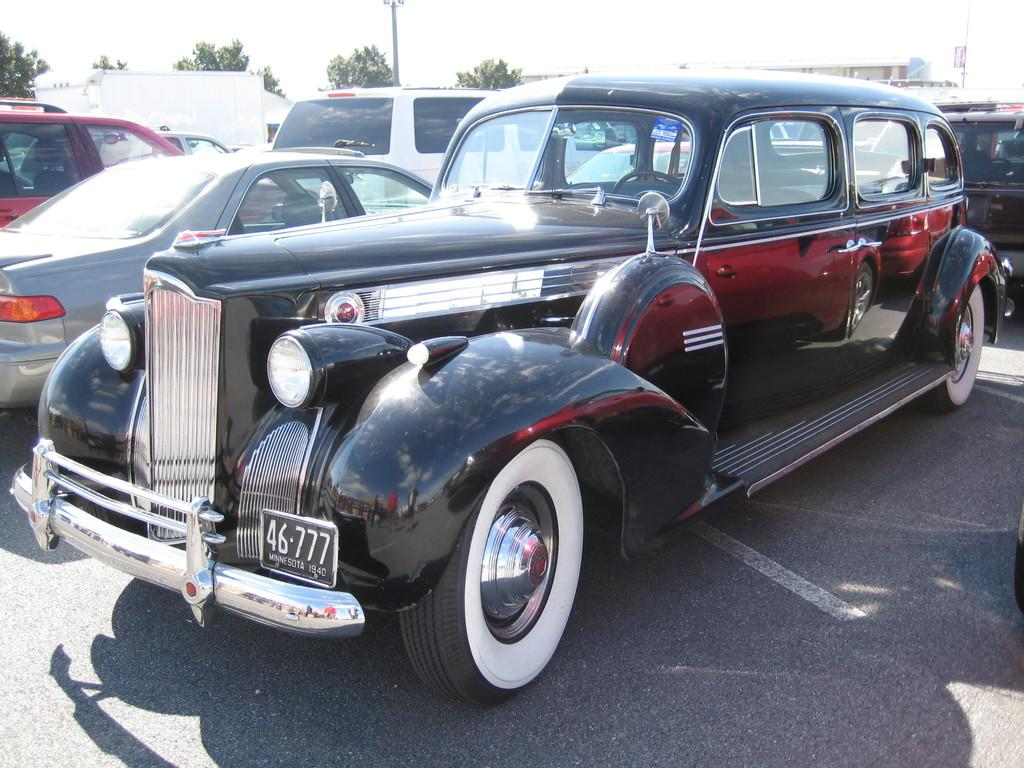What can be seen on the road in the image? There are cars parked on the road. What type of natural elements are visible in the background? Trees are visible in the background. What man-made structure is present in the background? A pole is present in the background. What type of human-made structures are visible in the background? There are buildings in the background. What part of the natural environment is visible in the image? The sky is visible in the background. What type of soap is being used to wash the cars in the image? There is no indication in the image that the cars are being washed, and therefore no soap can be observed. 